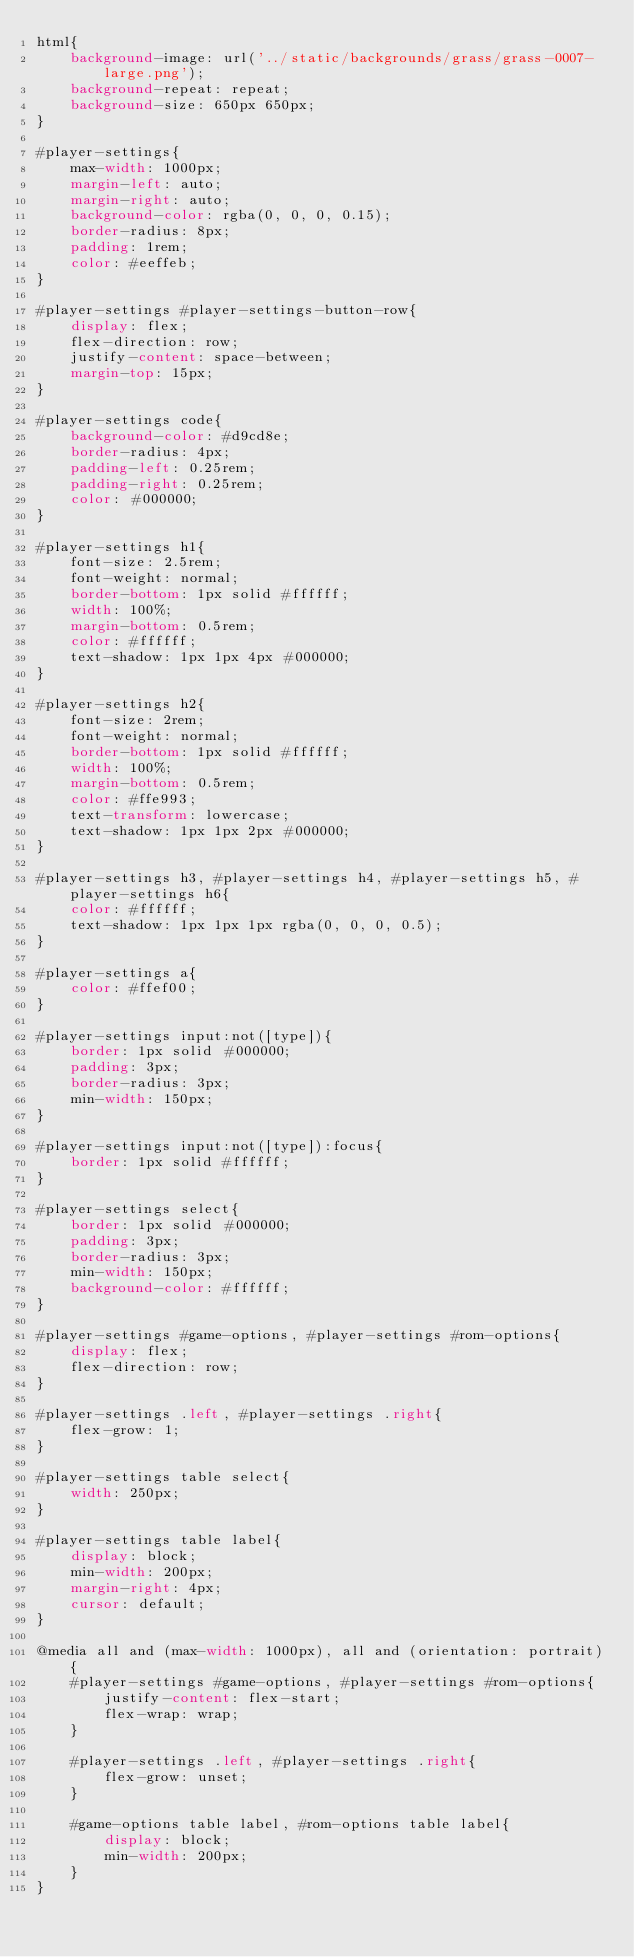<code> <loc_0><loc_0><loc_500><loc_500><_CSS_>html{
    background-image: url('../static/backgrounds/grass/grass-0007-large.png');
    background-repeat: repeat;
    background-size: 650px 650px;
}

#player-settings{
    max-width: 1000px;
    margin-left: auto;
    margin-right: auto;
    background-color: rgba(0, 0, 0, 0.15);
    border-radius: 8px;
    padding: 1rem;
    color: #eeffeb;
}

#player-settings #player-settings-button-row{
    display: flex;
    flex-direction: row;
    justify-content: space-between;
    margin-top: 15px;
}

#player-settings code{
    background-color: #d9cd8e;
    border-radius: 4px;
    padding-left: 0.25rem;
    padding-right: 0.25rem;
    color: #000000;
}

#player-settings h1{
    font-size: 2.5rem;
    font-weight: normal;
    border-bottom: 1px solid #ffffff;
    width: 100%;
    margin-bottom: 0.5rem;
    color: #ffffff;
    text-shadow: 1px 1px 4px #000000;
}

#player-settings h2{
    font-size: 2rem;
    font-weight: normal;
    border-bottom: 1px solid #ffffff;
    width: 100%;
    margin-bottom: 0.5rem;
    color: #ffe993;
    text-transform: lowercase;
    text-shadow: 1px 1px 2px #000000;
}

#player-settings h3, #player-settings h4, #player-settings h5, #player-settings h6{
    color: #ffffff;
    text-shadow: 1px 1px 1px rgba(0, 0, 0, 0.5);
}

#player-settings a{
    color: #ffef00;
}

#player-settings input:not([type]){
    border: 1px solid #000000;
    padding: 3px;
    border-radius: 3px;
    min-width: 150px;
}

#player-settings input:not([type]):focus{
    border: 1px solid #ffffff;
}

#player-settings select{
    border: 1px solid #000000;
    padding: 3px;
    border-radius: 3px;
    min-width: 150px;
    background-color: #ffffff;
}

#player-settings #game-options, #player-settings #rom-options{
    display: flex;
    flex-direction: row;
}

#player-settings .left, #player-settings .right{
    flex-grow: 1;
}

#player-settings table select{
    width: 250px;
}

#player-settings table label{
    display: block;
    min-width: 200px;
    margin-right: 4px;
    cursor: default;
}

@media all and (max-width: 1000px), all and (orientation: portrait){
    #player-settings #game-options, #player-settings #rom-options{
        justify-content: flex-start;
        flex-wrap: wrap;
    }

    #player-settings .left, #player-settings .right{
        flex-grow: unset;
    }

    #game-options table label, #rom-options table label{
        display: block;
        min-width: 200px;
    }
}
</code> 